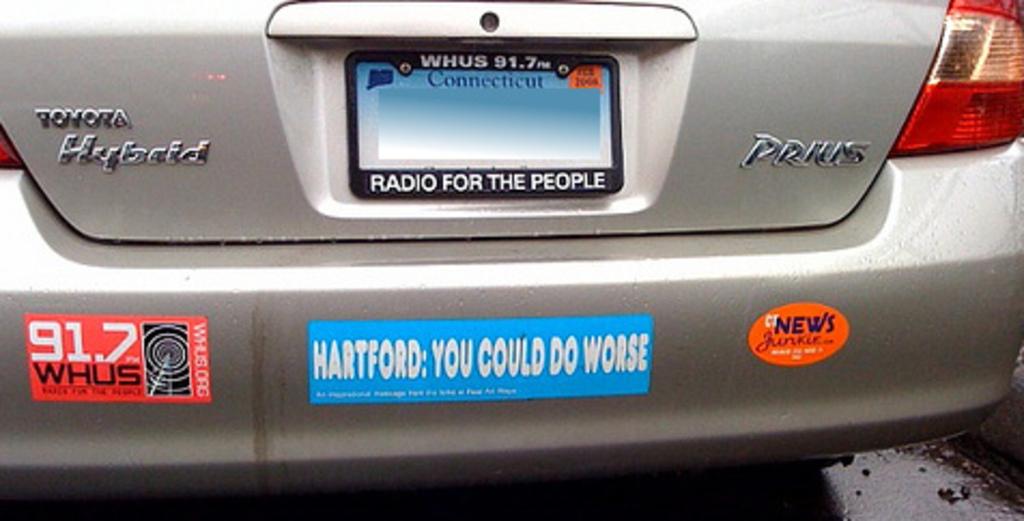What kind of car is this?
Your answer should be compact. Toyota prius. What state is the license plate from?
Make the answer very short. Connecticut. 